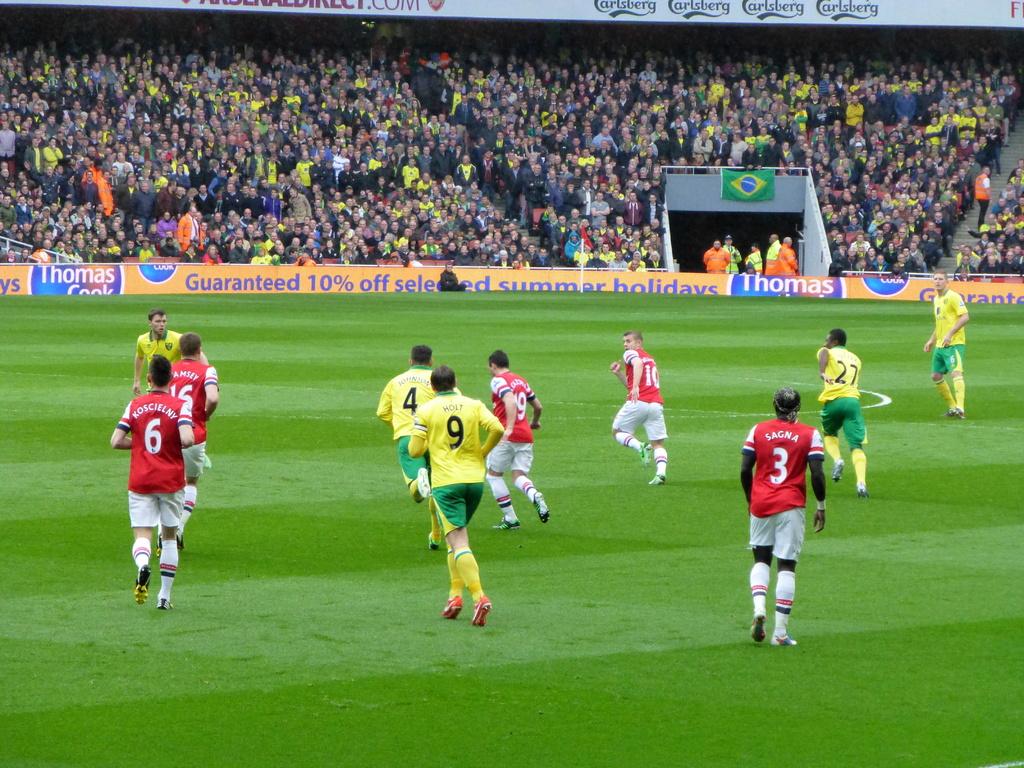Where is sagna in this picture?
Offer a terse response. Bottom right. What is the man on the left in reds jersey number?
Give a very brief answer. 6. 